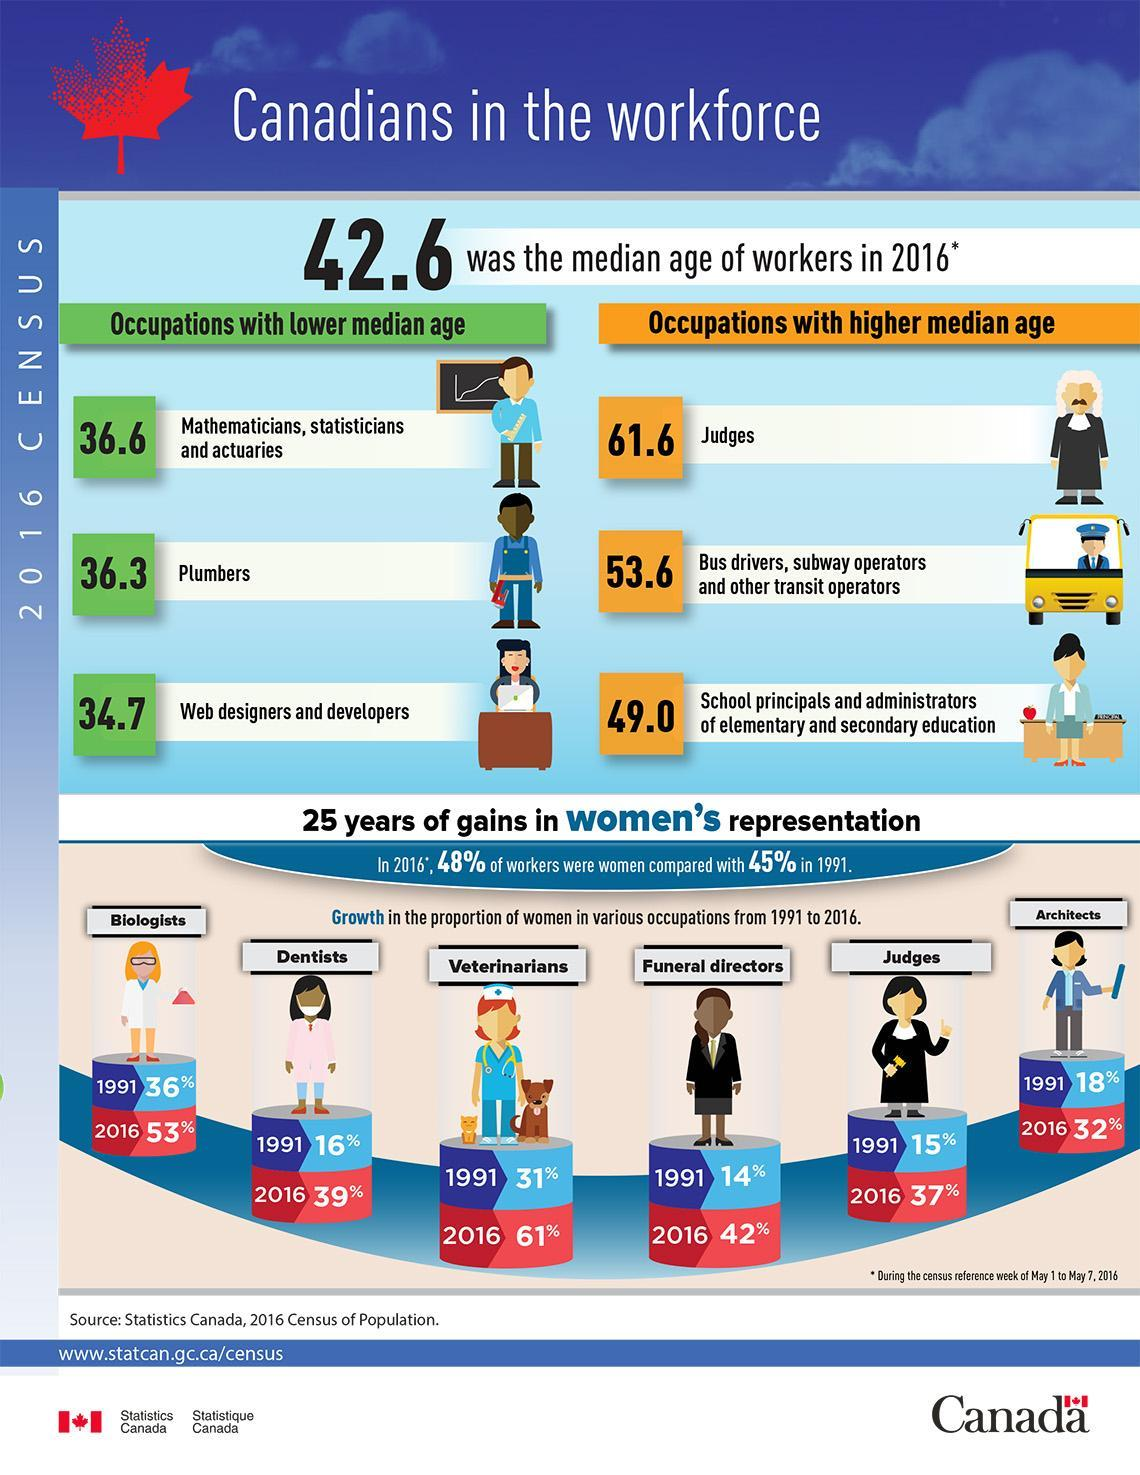What is the median age of plumbers in Canada in 2016?
Answer the question with a short phrase. 36.3 Which occupation in Canada has the highest median age in 2016? Judges What percentage of Canadian women are veterinarians in 1991? 31% What percentage of Canadian women are dentists in 2016? 39% What percentage of Canadian women are Architects in 2016? 32% 